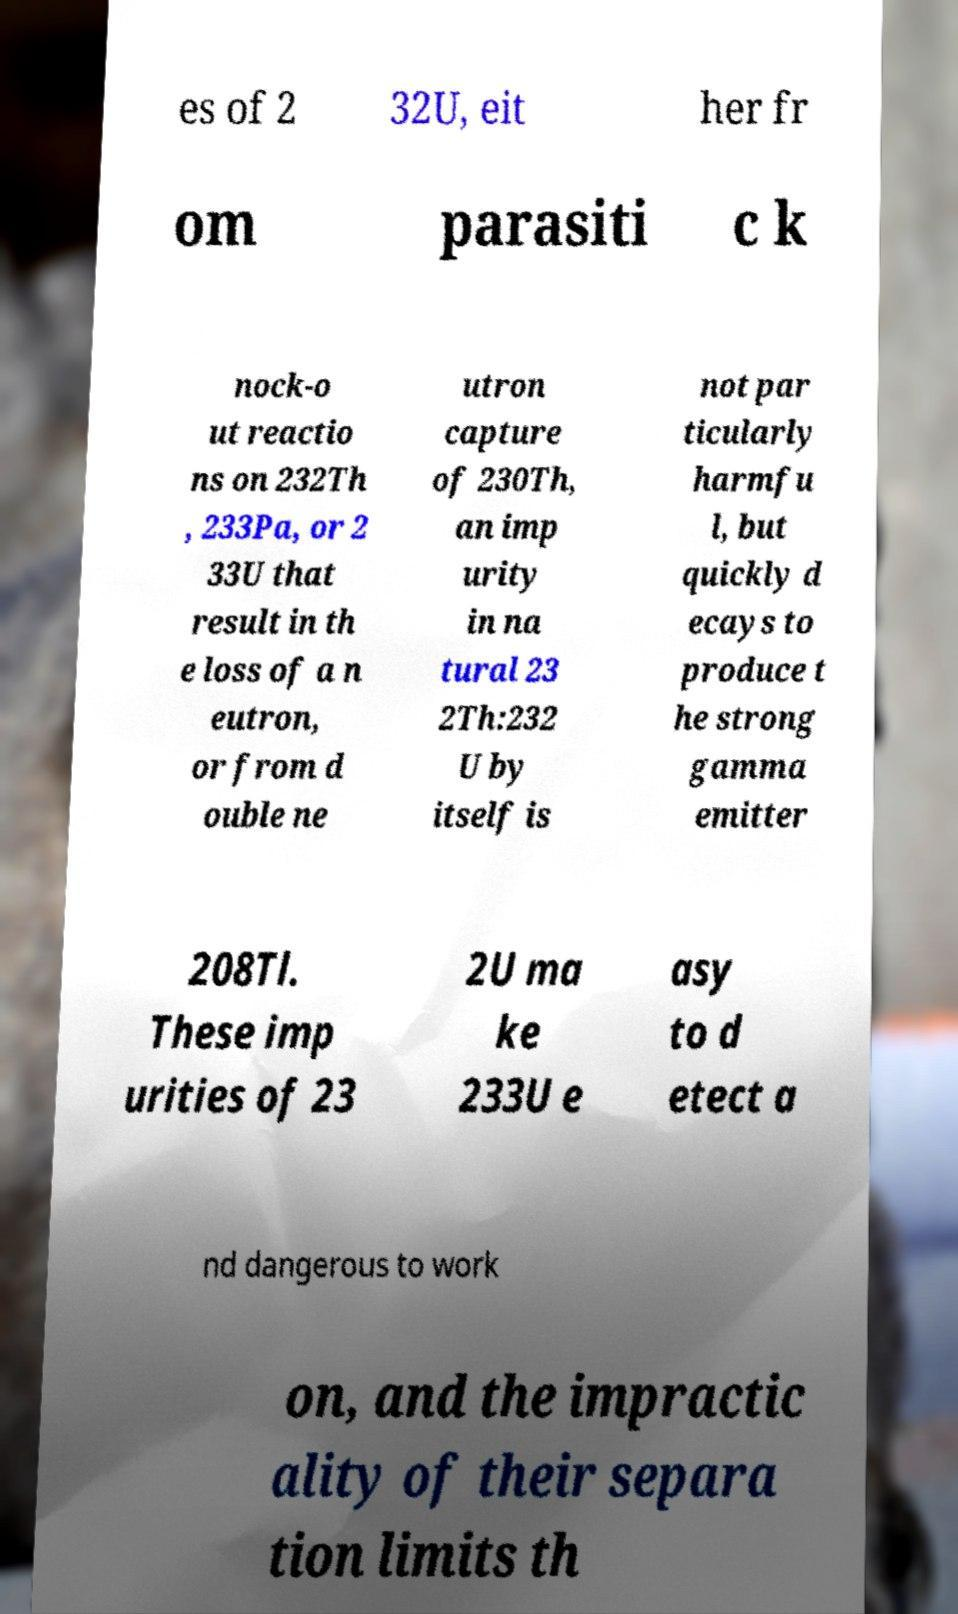Can you accurately transcribe the text from the provided image for me? es of 2 32U, eit her fr om parasiti c k nock-o ut reactio ns on 232Th , 233Pa, or 2 33U that result in th e loss of a n eutron, or from d ouble ne utron capture of 230Th, an imp urity in na tural 23 2Th:232 U by itself is not par ticularly harmfu l, but quickly d ecays to produce t he strong gamma emitter 208Tl. These imp urities of 23 2U ma ke 233U e asy to d etect a nd dangerous to work on, and the impractic ality of their separa tion limits th 